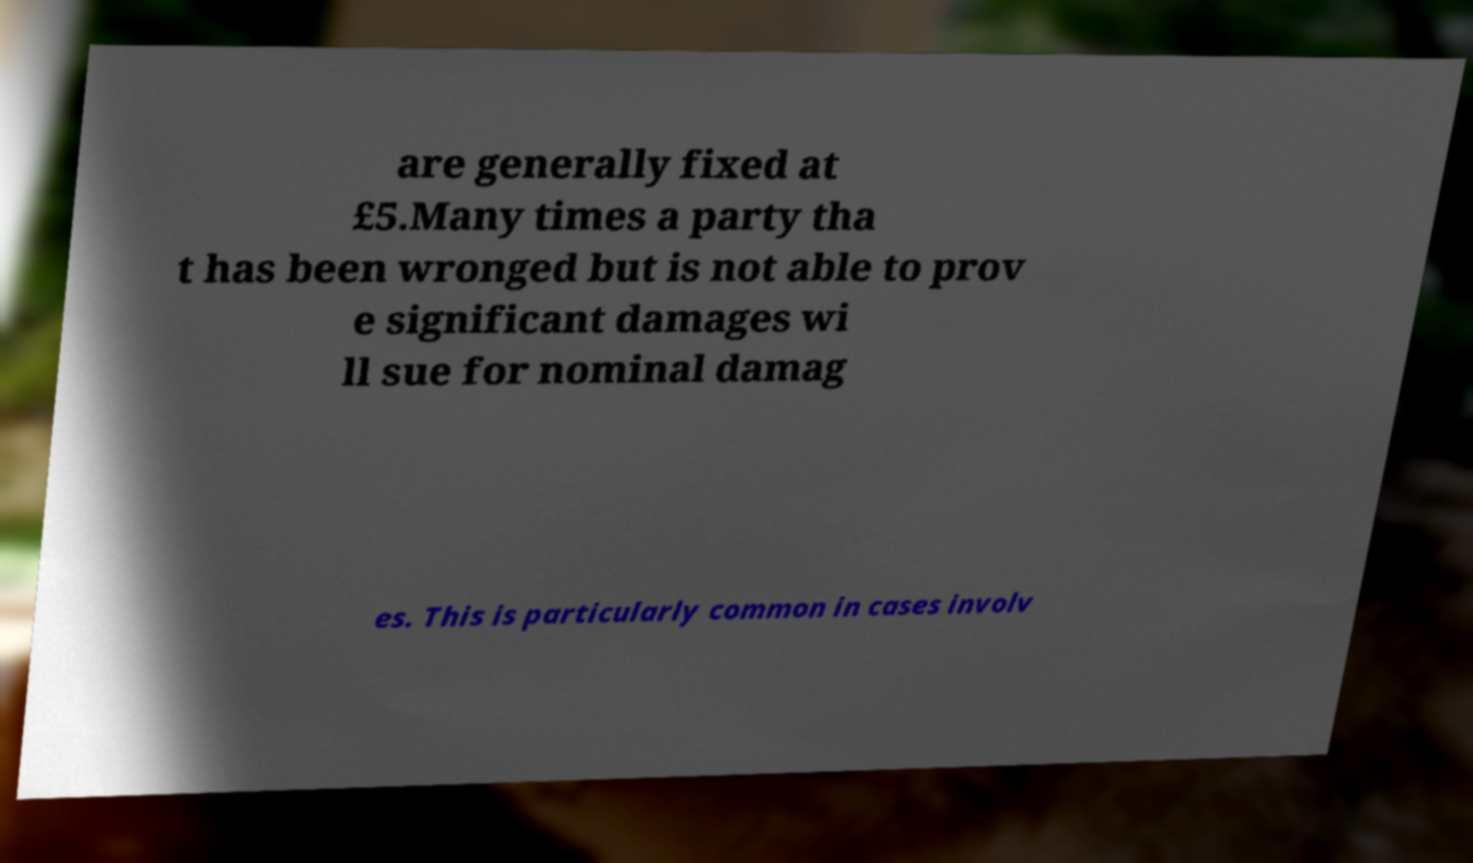I need the written content from this picture converted into text. Can you do that? are generally fixed at £5.Many times a party tha t has been wronged but is not able to prov e significant damages wi ll sue for nominal damag es. This is particularly common in cases involv 